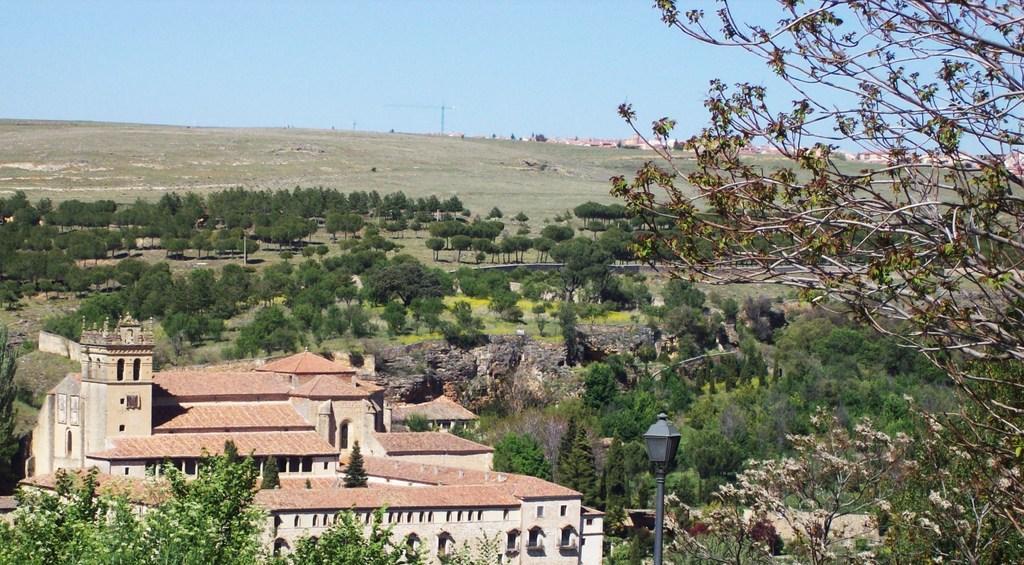Please provide a concise description of this image. This looks like a building with windows. I can see the trees. This looks like a hill. I think this is the light pole. In the background, I can see a pole and few buildings. 